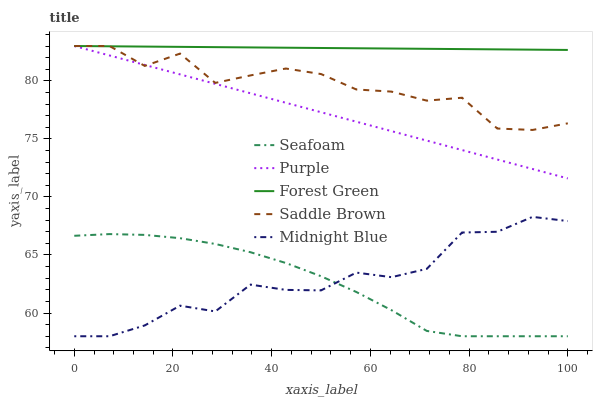Does Midnight Blue have the minimum area under the curve?
Answer yes or no. No. Does Midnight Blue have the maximum area under the curve?
Answer yes or no. No. Is Forest Green the smoothest?
Answer yes or no. No. Is Forest Green the roughest?
Answer yes or no. No. Does Forest Green have the lowest value?
Answer yes or no. No. Does Midnight Blue have the highest value?
Answer yes or no. No. Is Seafoam less than Forest Green?
Answer yes or no. Yes. Is Forest Green greater than Midnight Blue?
Answer yes or no. Yes. Does Seafoam intersect Forest Green?
Answer yes or no. No. 